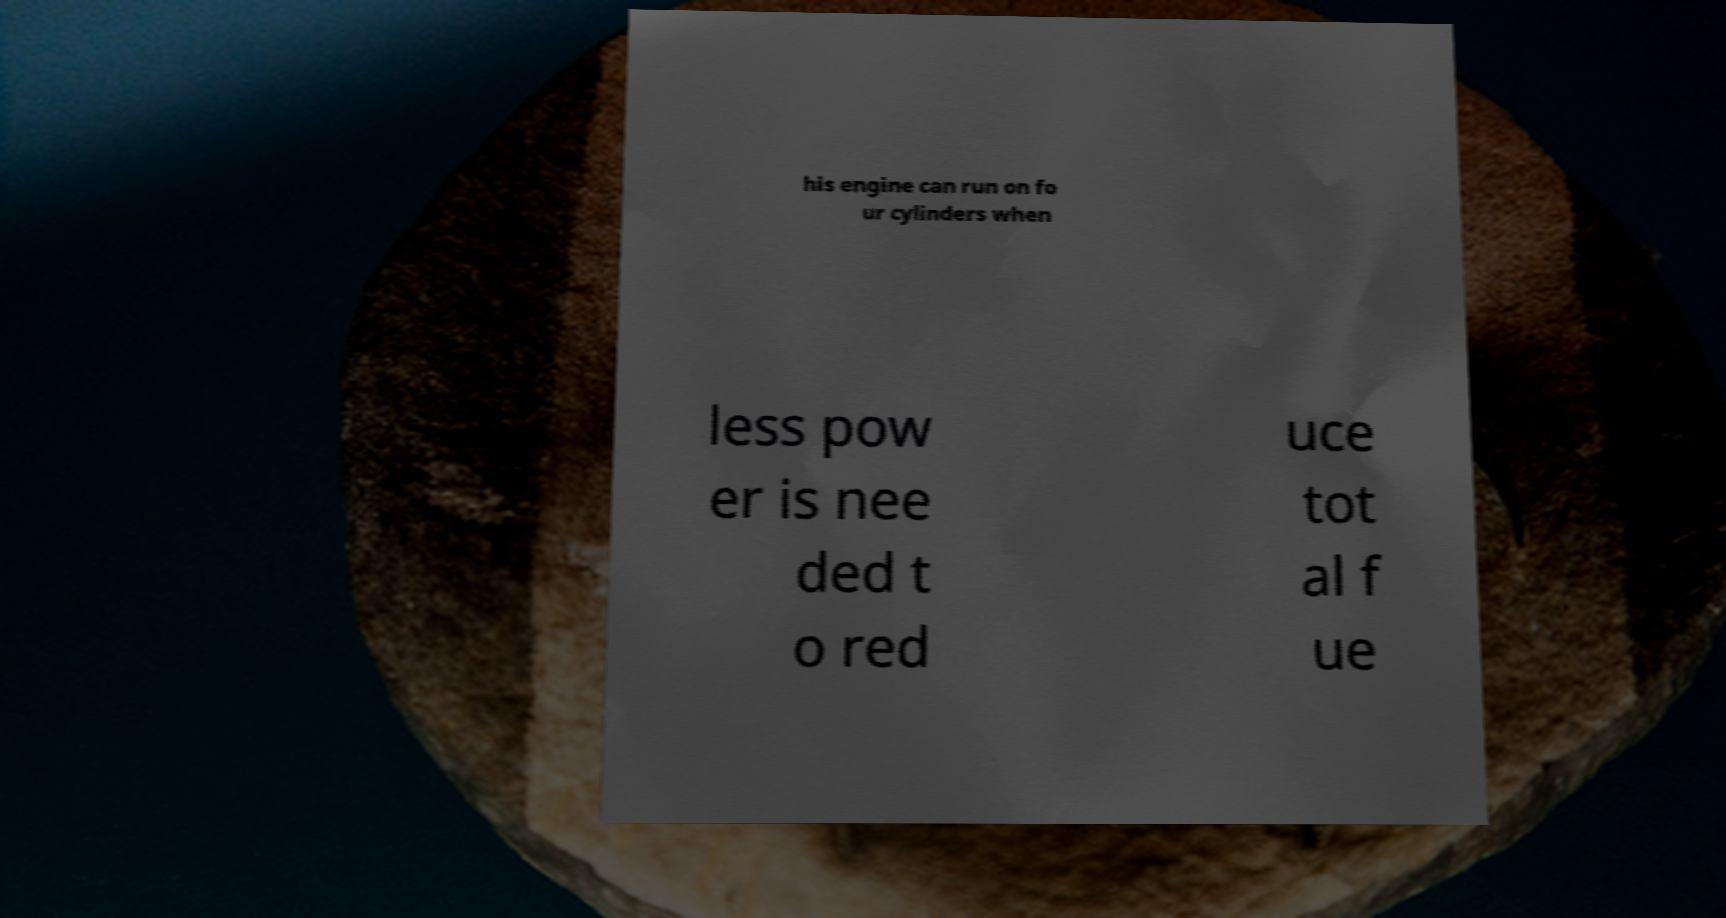Can you read and provide the text displayed in the image?This photo seems to have some interesting text. Can you extract and type it out for me? his engine can run on fo ur cylinders when less pow er is nee ded t o red uce tot al f ue 